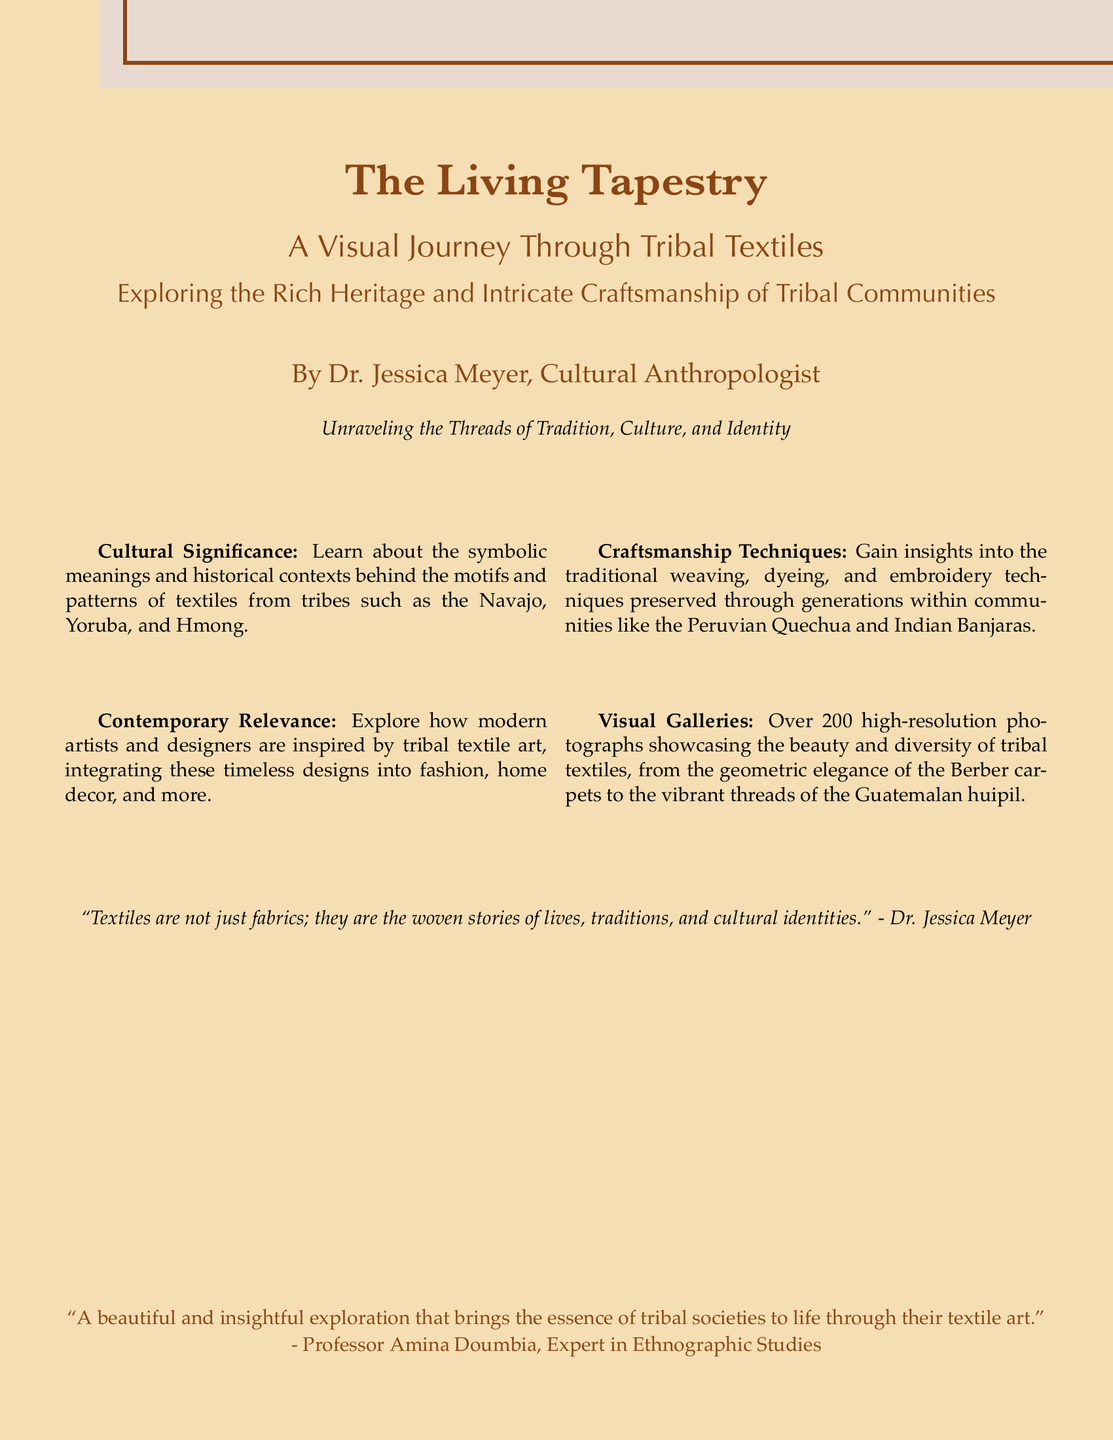What is the title of the book? The title of the book is presented prominently on the cover in a large font.
Answer: The Living Tapestry Who is the author of the book? The author is indicated under the title, providing their name and profession.
Answer: Dr. Jessica Meyer What is the subtitle of the book? The subtitle offers a descriptive insight into the book's theme and focus.
Answer: A Visual Journey Through Tribal Textiles How many high-resolution photographs are featured in the book? The document states the number of photographs included in the visual galleries section.
Answer: Over 200 What communities are mentioned in the cultural significance section? Specific tribes are listed that the book explores in terms of their textile traditions.
Answer: Navajo, Yoruba, Hmong What is the main theme explored in the book? The text summarizes the overarching concept that ties the various elements of the book together.
Answer: Tradition, Culture, and Identity Which expert endorsed the book? The name of the person providing a quote of praise for the book is found at the end of the cover.
Answer: Professor Amina Doumbia What techniques are highlighted in the craftsmanship section? The document specifies various textile-making techniques that the book discusses.
Answer: Weaving, dyeing, embroidery What is the color of the book cover? The cover color is described at the beginning of the document and can be identified visually.
Answer: Covercolor (beige tone) 